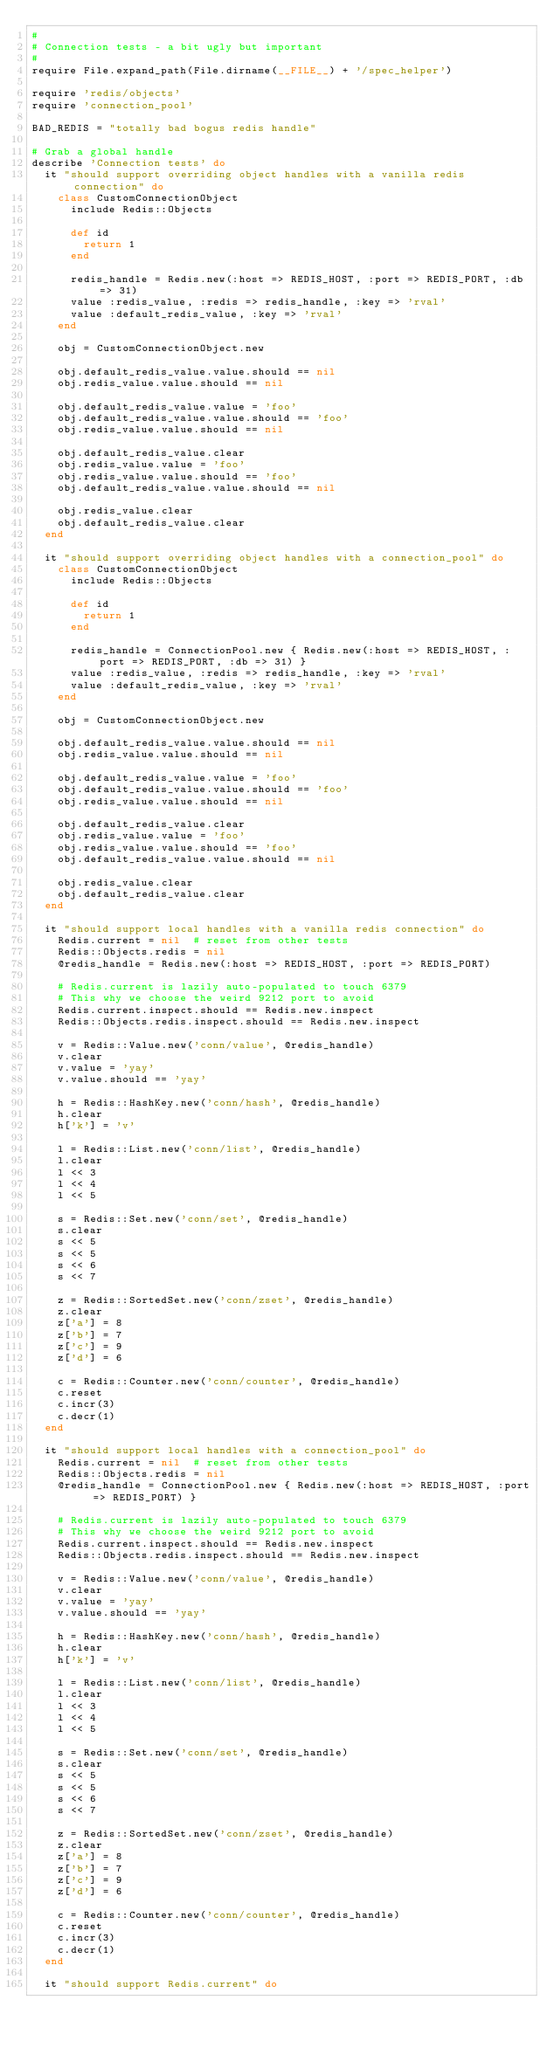Convert code to text. <code><loc_0><loc_0><loc_500><loc_500><_Ruby_>#
# Connection tests - a bit ugly but important
#
require File.expand_path(File.dirname(__FILE__) + '/spec_helper')

require 'redis/objects'
require 'connection_pool'

BAD_REDIS = "totally bad bogus redis handle"

# Grab a global handle
describe 'Connection tests' do
  it "should support overriding object handles with a vanilla redis connection" do
    class CustomConnectionObject
      include Redis::Objects

      def id
        return 1
      end

      redis_handle = Redis.new(:host => REDIS_HOST, :port => REDIS_PORT, :db => 31)
      value :redis_value, :redis => redis_handle, :key => 'rval'
      value :default_redis_value, :key => 'rval'
    end

    obj = CustomConnectionObject.new

    obj.default_redis_value.value.should == nil
    obj.redis_value.value.should == nil

    obj.default_redis_value.value = 'foo'
    obj.default_redis_value.value.should == 'foo'
    obj.redis_value.value.should == nil

    obj.default_redis_value.clear
    obj.redis_value.value = 'foo'
    obj.redis_value.value.should == 'foo'
    obj.default_redis_value.value.should == nil

    obj.redis_value.clear
    obj.default_redis_value.clear
  end

  it "should support overriding object handles with a connection_pool" do
    class CustomConnectionObject
      include Redis::Objects

      def id
        return 1
      end

      redis_handle = ConnectionPool.new { Redis.new(:host => REDIS_HOST, :port => REDIS_PORT, :db => 31) }
      value :redis_value, :redis => redis_handle, :key => 'rval'
      value :default_redis_value, :key => 'rval'
    end

    obj = CustomConnectionObject.new

    obj.default_redis_value.value.should == nil
    obj.redis_value.value.should == nil

    obj.default_redis_value.value = 'foo'
    obj.default_redis_value.value.should == 'foo'
    obj.redis_value.value.should == nil

    obj.default_redis_value.clear
    obj.redis_value.value = 'foo'
    obj.redis_value.value.should == 'foo'
    obj.default_redis_value.value.should == nil

    obj.redis_value.clear
    obj.default_redis_value.clear
  end

  it "should support local handles with a vanilla redis connection" do
    Redis.current = nil  # reset from other tests
    Redis::Objects.redis = nil
    @redis_handle = Redis.new(:host => REDIS_HOST, :port => REDIS_PORT)

    # Redis.current is lazily auto-populated to touch 6379
    # This why we choose the weird 9212 port to avoid
    Redis.current.inspect.should == Redis.new.inspect
    Redis::Objects.redis.inspect.should == Redis.new.inspect

    v = Redis::Value.new('conn/value', @redis_handle)
    v.clear
    v.value = 'yay'
    v.value.should == 'yay'

    h = Redis::HashKey.new('conn/hash', @redis_handle)
    h.clear
    h['k'] = 'v'

    l = Redis::List.new('conn/list', @redis_handle)
    l.clear
    l << 3
    l << 4
    l << 5

    s = Redis::Set.new('conn/set', @redis_handle)
    s.clear
    s << 5
    s << 5
    s << 6
    s << 7

    z = Redis::SortedSet.new('conn/zset', @redis_handle)
    z.clear
    z['a'] = 8
    z['b'] = 7
    z['c'] = 9
    z['d'] = 6

    c = Redis::Counter.new('conn/counter', @redis_handle)
    c.reset
    c.incr(3)
    c.decr(1)
  end

  it "should support local handles with a connection_pool" do
    Redis.current = nil  # reset from other tests
    Redis::Objects.redis = nil
    @redis_handle = ConnectionPool.new { Redis.new(:host => REDIS_HOST, :port => REDIS_PORT) }

    # Redis.current is lazily auto-populated to touch 6379
    # This why we choose the weird 9212 port to avoid
    Redis.current.inspect.should == Redis.new.inspect
    Redis::Objects.redis.inspect.should == Redis.new.inspect

    v = Redis::Value.new('conn/value', @redis_handle)
    v.clear
    v.value = 'yay'
    v.value.should == 'yay'

    h = Redis::HashKey.new('conn/hash', @redis_handle)
    h.clear
    h['k'] = 'v'

    l = Redis::List.new('conn/list', @redis_handle)
    l.clear
    l << 3
    l << 4
    l << 5

    s = Redis::Set.new('conn/set', @redis_handle)
    s.clear
    s << 5
    s << 5
    s << 6
    s << 7

    z = Redis::SortedSet.new('conn/zset', @redis_handle)
    z.clear
    z['a'] = 8
    z['b'] = 7
    z['c'] = 9
    z['d'] = 6

    c = Redis::Counter.new('conn/counter', @redis_handle)
    c.reset
    c.incr(3)
    c.decr(1)
  end

  it "should support Redis.current" do</code> 